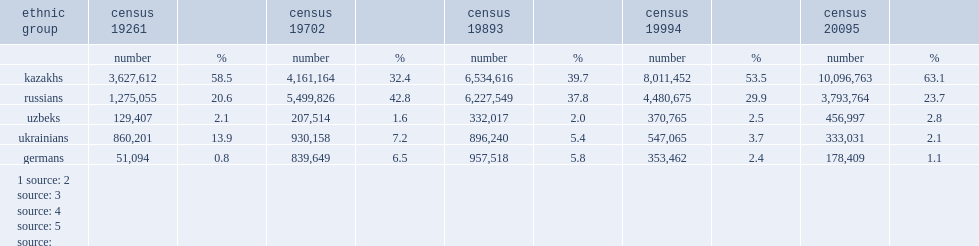What was the population(%)of ethnic kazakhs in the census 20095? 63.1. 